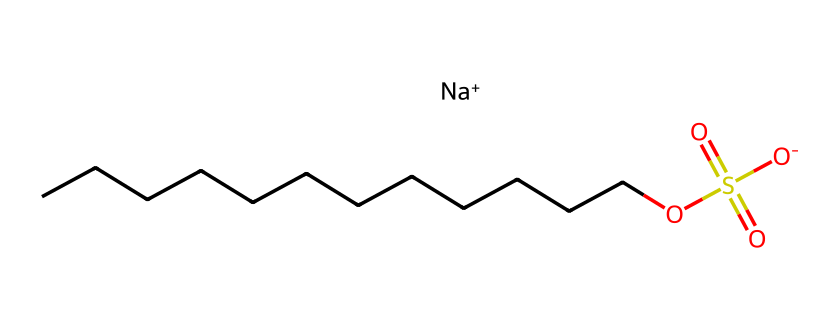How many carbon atoms are in sodium dodecyl sulfate? The SMILES representation shows a long chain of carbon atoms at the beginning (CCCCCCCCCCCC), which indicates there are twelve carbon atoms.
Answer: twelve What is the functional group present in sodium dodecyl sulfate? The part of the chemical structure with "OS(=O)(=O)O" represents the sulfonate group, which is a characteristic functional group in this molecule.
Answer: sulfonate What is the total charge of sodium dodecyl sulfate? The SMILES indicates the presence of "[Na+]", which signifies a positive charge, while the sulfonate group has a negative charge "[O-]", leading to a net neutral overall. However, it can be typically referred as having a net charge of zero when counting the overall in solution.
Answer: zero What is the role of sodium in sodium dodecyl sulfate? Sodium is present as a counterion to balance the negative charge of the sulfonate group, ensuring the molecule remains electrically neutral in solution.
Answer: counterion What type of surfactant is sodium dodecyl sulfate classified as? Given its structure with a long hydrophobic carbon chain and a hydrophilic sulfonate head, it is classified as an anionic surfactant, which is effective in lowering surface tension in water.
Answer: anionic surfactant 